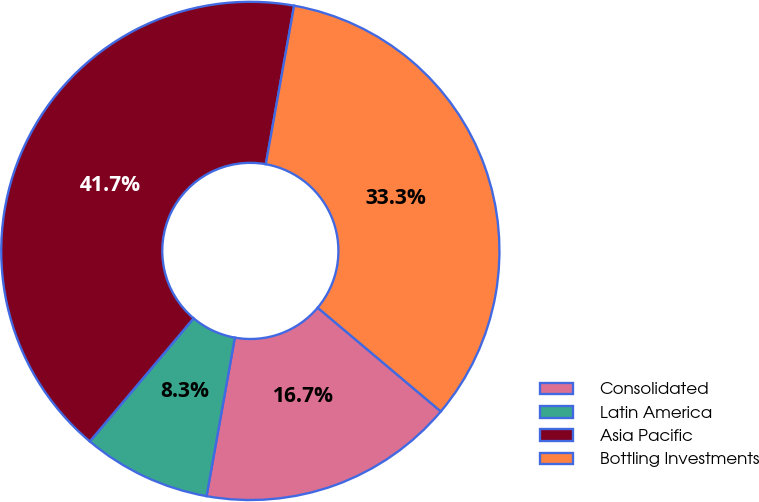Convert chart. <chart><loc_0><loc_0><loc_500><loc_500><pie_chart><fcel>Consolidated<fcel>Latin America<fcel>Asia Pacific<fcel>Bottling Investments<nl><fcel>16.67%<fcel>8.33%<fcel>41.67%<fcel>33.33%<nl></chart> 